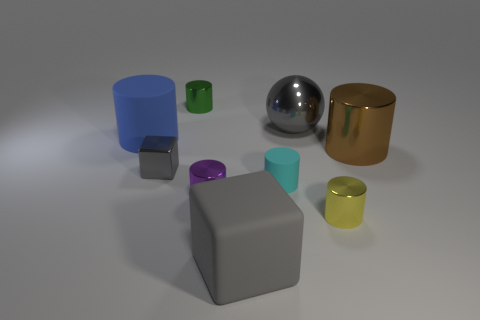Is the color of the small metal cube the same as the matte block?
Ensure brevity in your answer.  Yes. There is a gray object that is both in front of the blue rubber cylinder and right of the tiny purple metallic cylinder; what shape is it?
Provide a short and direct response. Cube. How many other things are the same color as the shiny cube?
Your answer should be very brief. 2. The big blue rubber object is what shape?
Your answer should be very brief. Cylinder. There is a big matte thing in front of the cyan rubber cylinder that is behind the small yellow object; what is its color?
Give a very brief answer. Gray. There is a large metallic cylinder; is its color the same as the rubber cylinder that is behind the small metal block?
Offer a terse response. No. What material is the gray object that is behind the purple metal cylinder and on the right side of the small gray block?
Give a very brief answer. Metal. Is there a blue shiny cylinder that has the same size as the yellow shiny thing?
Your answer should be compact. No. There is a gray object that is the same size as the cyan matte thing; what is its material?
Offer a terse response. Metal. How many small green shiny objects are in front of the green cylinder?
Provide a succinct answer. 0. 